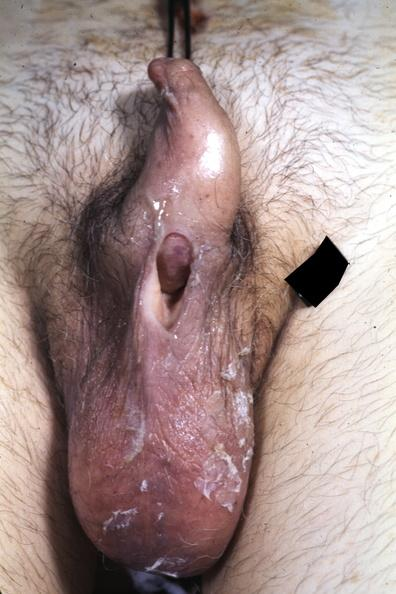s hypospadias present?
Answer the question using a single word or phrase. Yes 